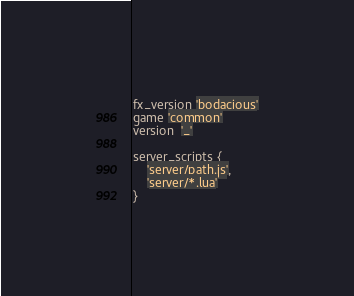<code> <loc_0><loc_0><loc_500><loc_500><_Lua_>fx_version 'bodacious'
game 'common'
version  '_'

server_scripts {
    'server/path.js',
    'server/*.lua'
}

</code> 